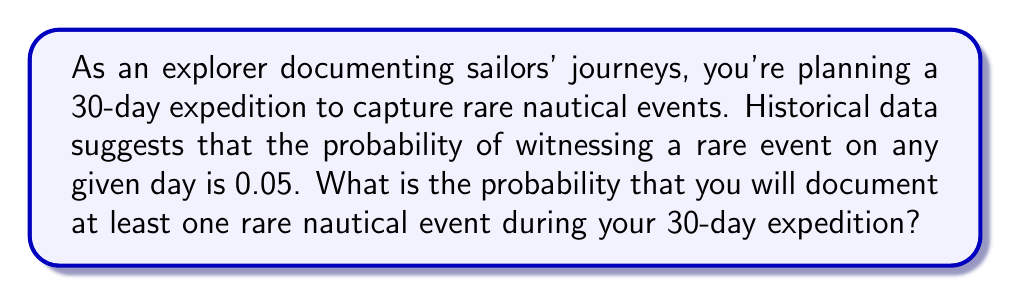Could you help me with this problem? Let's approach this step-by-step:

1) First, let's define our events:
   - Success: Documenting at least one rare nautical event
   - Failure: Not documenting any rare nautical events

2) It's easier to calculate the probability of failure and then subtract from 1 to get the probability of success.

3) The probability of not witnessing a rare event on a single day is:
   $1 - 0.05 = 0.95$

4) For the entire 30-day expedition to be a failure, we need to not witness a rare event for 30 consecutive days. The probability of this is:
   $0.95^{30}$

5) Now, we can calculate the probability of success:
   $P(\text{at least one rare event}) = 1 - P(\text{no rare events})$
   $= 1 - 0.95^{30}$

6) Let's calculate this:
   $1 - 0.95^{30} = 1 - 0.2146$
   $= 0.7854$

7) Converting to a percentage:
   $0.7854 \times 100\% = 78.54\%$

Therefore, the probability of documenting at least one rare nautical event during the 30-day expedition is approximately 78.54%.
Answer: 78.54% 